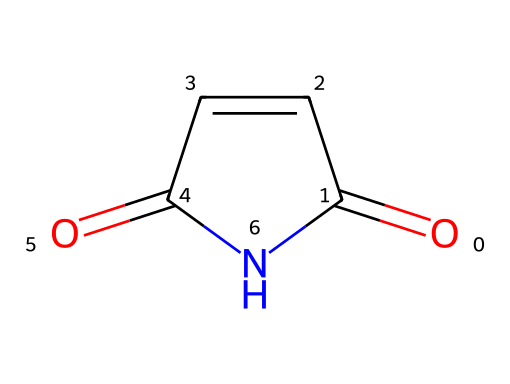What is the molecular formula of this compound? By analyzing the structure, we count the number of each atom present. The SMILES representation shows 4 carbons, 4 hydrogens, 2 oxygens, and 1 nitrogen. Summarizing this gives us the molecular formula C4H4N2O2.
Answer: C4H4N2O2 How many rings are present in the structure? The structure displays a cyclic formation, indicating it contains one ring as evidenced by the label "C1" in the SMILES notation which denotes the bond connection at that point.
Answer: 1 What functional groups are present in this molecule? Examining the structure, we identify a carbonyl group (C=O) and an imide group (C=O directly bonded to nitrogen) from the presence of the nitrogen and the two carbonyls. Therefore, the functional groups in this molecule are carbonyl and imide.
Answer: carbonyl, imide Is this compound likely to be hydrophilic or hydrophobic? The presence of polar functional groups (carbonyls and nitrogen) indicates that this compound is likely to interact favorably with water, suggesting hydrophilicity.
Answer: hydrophilic What is the significance of the nitrogen atom in this compound? The nitrogen atom is crucial as it characterizes the molecule as an imide, affecting its reactivity and interactions, especially in water treatment applications where these properties are vital.
Answer: imide What type of reaction is typically used to synthesize maleimide? Maleimide is usually synthesized through the reaction of maleic anhydride with ammonia (or an amine), a common method for creating imides.
Answer: condensation reaction 